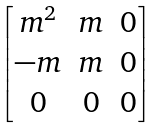<formula> <loc_0><loc_0><loc_500><loc_500>\begin{bmatrix} m ^ { 2 } & m & 0 \\ - m & m & 0 \\ 0 & 0 & 0 \\ \end{bmatrix}</formula> 